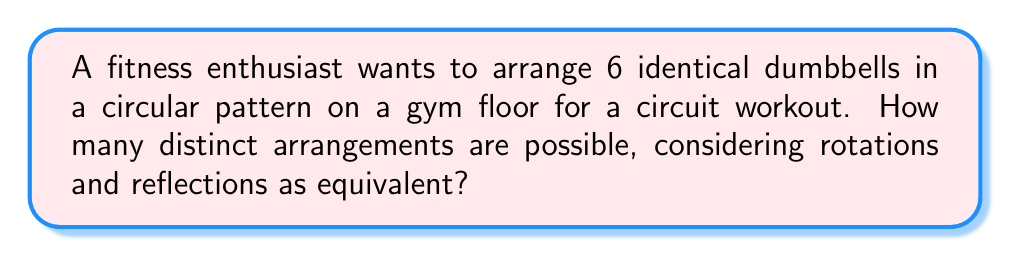Can you answer this question? To solve this problem, we need to use concepts from group theory, specifically the dihedral group $D_6$. Here's a step-by-step explanation:

1) First, we need to understand that this problem is equivalent to finding the number of symmetries of a regular hexagon, as the dumbbells are arranged in a circular pattern with 6 positions.

2) The symmetry group of a regular hexagon is the dihedral group $D_6$. This group includes both rotational and reflectional symmetries.

3) The order of the dihedral group $D_6$ is given by the formula:

   $$|D_6| = 2n$$

   where $n$ is the number of sides (in this case, 6).

4) Therefore, the number of symmetries is:

   $$|D_6| = 2 \cdot 6 = 12$$

5) These 12 symmetries can be broken down as follows:
   - 6 rotational symmetries (including the identity rotation)
   - 6 reflectional symmetries

6) Each distinct arrangement of the dumbbells corresponds to one of these symmetries. Therefore, the number of distinct arrangements is equal to the total number of arrangements (6!) divided by the number of symmetries (12).

7) We can calculate this as:

   $$\text{Number of distinct arrangements} = \frac{6!}{12} = \frac{720}{12} = 60$$

Thus, there are 60 distinct arrangements of the dumbbells.
Answer: 60 distinct arrangements 